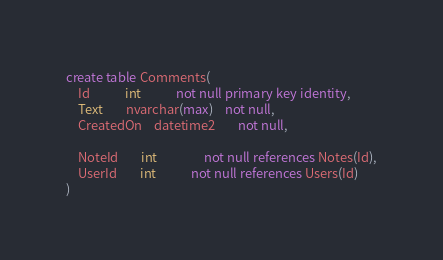<code> <loc_0><loc_0><loc_500><loc_500><_SQL_>create table Comments(
	Id			int 			not null primary key identity,
	Text		nvarchar(max)	not null,
	CreatedOn	datetime2		not null,

	NoteId		int				not null references Notes(Id),
	UserId		int 			not null references Users(Id)
)</code> 